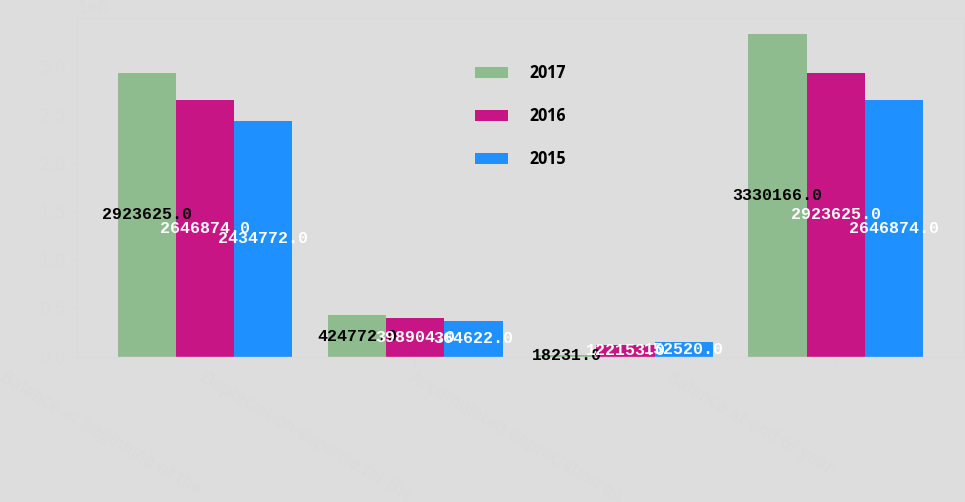<chart> <loc_0><loc_0><loc_500><loc_500><stacked_bar_chart><ecel><fcel>Balance at beginning of the<fcel>Depreciation expense for the<fcel>Accumulated depreciation on<fcel>Balance at end of year<nl><fcel>2017<fcel>2.92362e+06<fcel>424772<fcel>18231<fcel>3.33017e+06<nl><fcel>2016<fcel>2.64687e+06<fcel>398904<fcel>122153<fcel>2.92362e+06<nl><fcel>2015<fcel>2.43477e+06<fcel>364622<fcel>152520<fcel>2.64687e+06<nl></chart> 